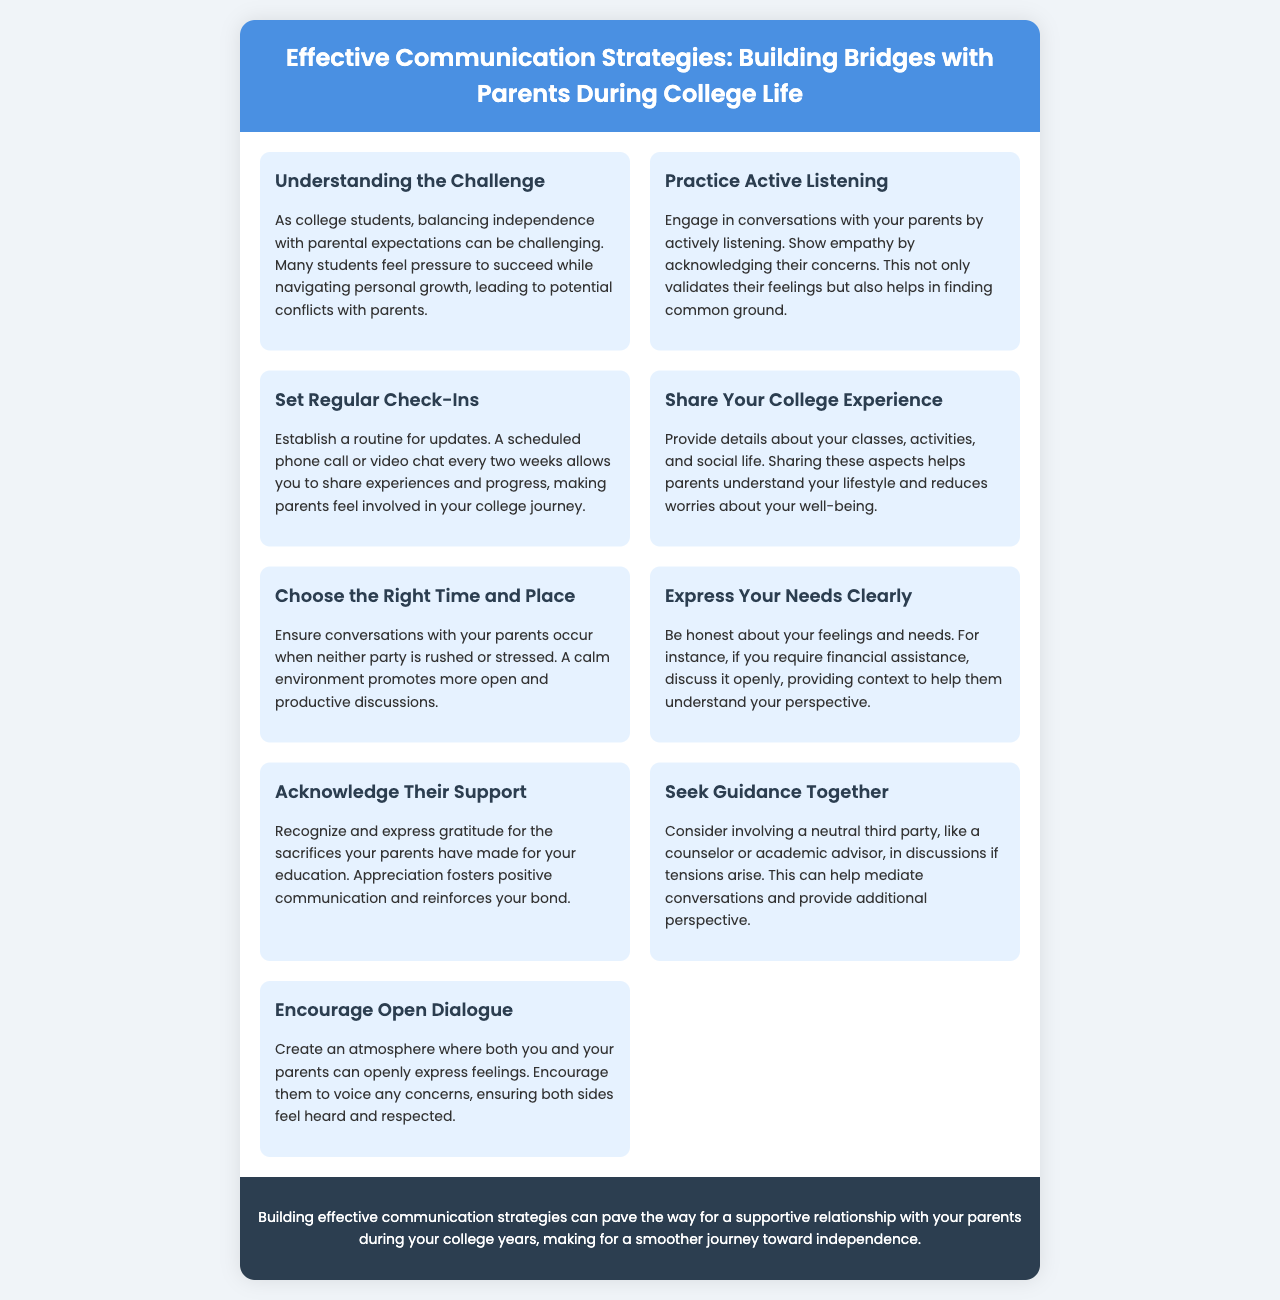What is the title of the brochure? The title is prominently displayed in the header of the document.
Answer: Effective Communication Strategies: Building Bridges with Parents During College Life How many sections are in the content? The brochure presents a total of 9 distinct sections detailing various communication strategies.
Answer: 9 What should you do to show empathy when talking to parents? Active listening is highlighted as a key strategy to show empathy towards parental concerns.
Answer: Practice Active Listening What is recommended for sharing experiences with parents? A scheduled phone call or video chat is suggested as a regular update routine with parents.
Answer: Set Regular Check-Ins What is the purpose of expressing gratitude to parents? Acknowledging their support helps foster positive communication and reinforces the bond between students and parents.
Answer: Acknowledge Their Support Which strategy involves a neutral third party? This section discusses the option of involving a counselor or academic advisor to help mediate discussions.
Answer: Seek Guidance Together What is critical when choosing a time for conversations? Selecting a calm environment where neither party feels rushed promotes better discussions.
Answer: Choose the Right Time and Place Why is sharing details about college life important? It helps parents to understand the student's lifestyle and reduces their worries about well-being.
Answer: Share Your College Experience How can students encourage communication from their parents? Creating an atmosphere for open dialogue encourages parents to voice their concerns.
Answer: Encourage Open Dialogue 